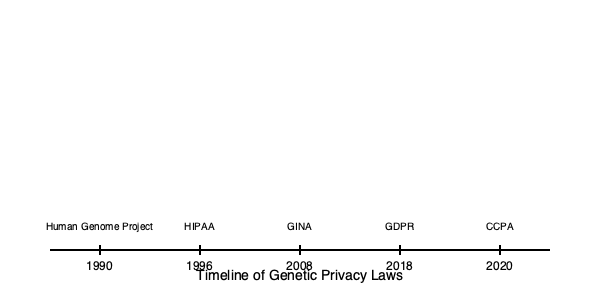Which landmark legislation, enacted in 2008, specifically addresses genetic discrimination in health insurance and employment, and how does it fit into the broader timeline of genetic privacy laws? To answer this question, let's examine the timeline of genetic privacy laws:

1. 1990: Human Genome Project begins, raising awareness about genetic information and its potential uses.

2. 1996: Health Insurance Portability and Accountability Act (HIPAA) is enacted, providing some protections for medical information, including genetic data.

3. 2008: Genetic Information Nondiscrimination Act (GINA) is passed. This is the legislation we're looking for, as it specifically addresses genetic discrimination in health insurance and employment.

4. 2018: General Data Protection Regulation (GDPR) is implemented in the EU, providing additional protections for personal data, including genetic information.

5. 2020: California Consumer Privacy Act (CCPA) goes into effect, offering California residents more control over their personal data, including genetic information.

GINA, enacted in 2008, stands out as the landmark legislation specifically addressing genetic discrimination. It prohibits health insurers from using genetic information to make coverage decisions and employers from using it in hiring, firing, or promotion decisions. This law filled a crucial gap in existing protections, as neither HIPAA nor other anti-discrimination laws adequately covered genetic information.

In the context of the timeline, GINA represents a significant milestone. It came after the initial awareness raised by the Human Genome Project and the broader medical privacy protections of HIPAA, but before the more comprehensive data protection regulations like GDPR and CCPA. This timing reflects the growing understanding of the importance of genetic privacy and the need for specific protections in this area.
Answer: Genetic Information Nondiscrimination Act (GINA) 